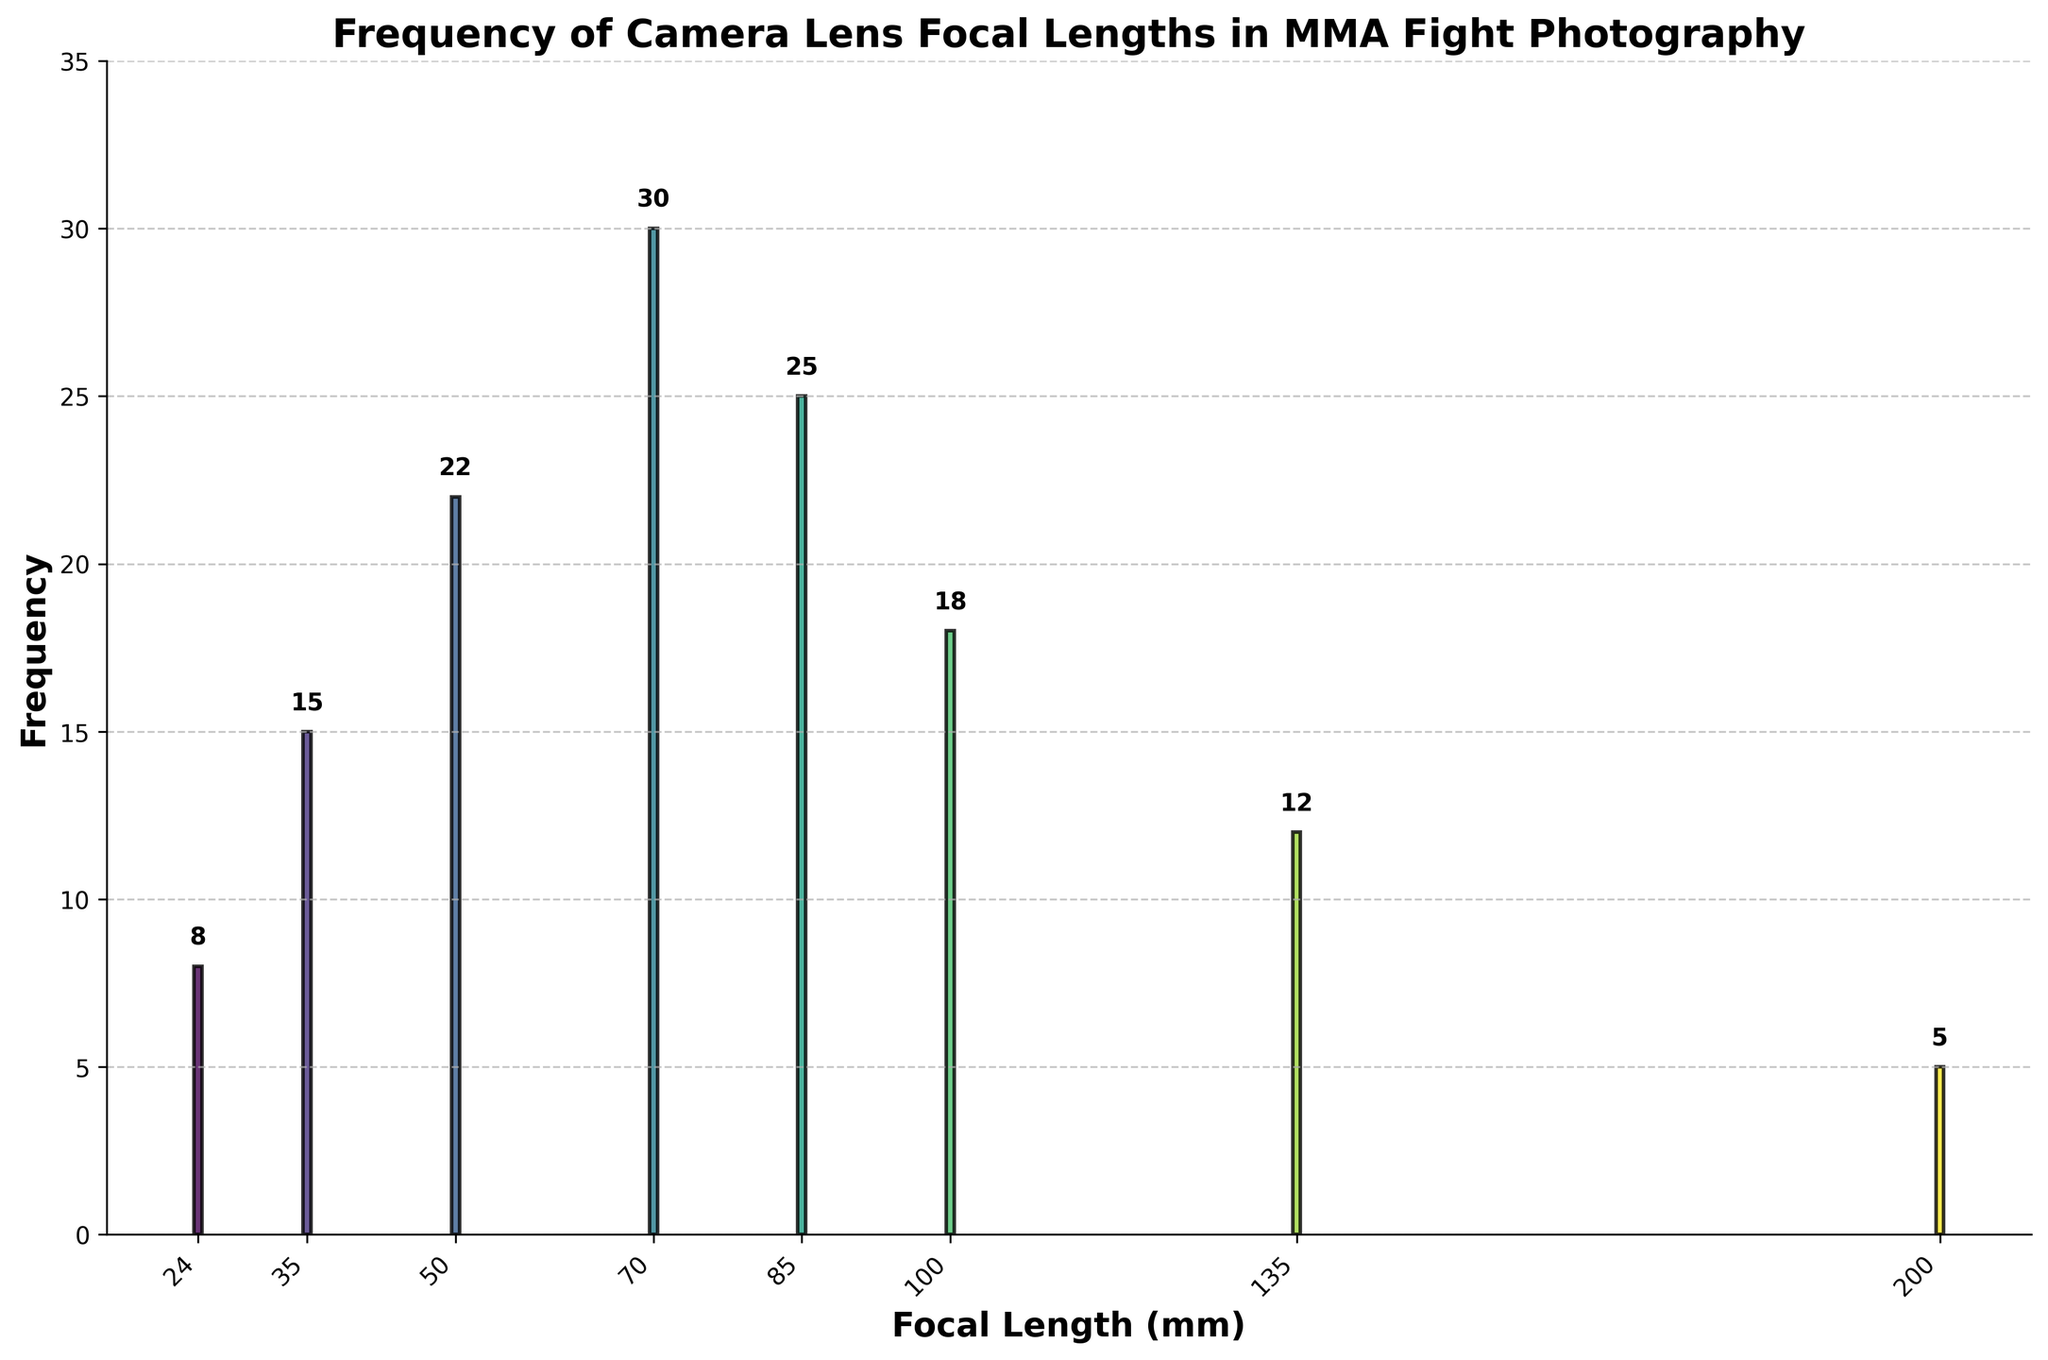What is the title of the figure? The title of the figure is displayed at the top in bold text.
Answer: Frequency of Camera Lens Focal Lengths in MMA Fight Photography Which focal length was used most frequently? The focal length with the highest bar indicates the most frequently used. According to the figure, the highest bar is at 70mm with a frequency of 30.
Answer: 70mm How many focal lengths are represented in the histogram? Each unique focal length corresponds to one bar in the histogram. Counting these bars gives the number of focal lengths represented.
Answer: 8 What is the combined frequency of the 24mm and 200mm focal lengths? The frequency of 24mm is 8 and for 200mm is 5. Adding these frequencies together gives the combined frequency. 8 + 5 = 13
Answer: 13 Which focal length range (short: 24-50mm, medium: 70-100mm, long: 135-200mm) is most frequently used? The sum of frequencies within each focal length range determines which is most frequently used. The short range sums to 45 (8+15+22), the medium range sums to 73 (30+25+18), and the long range sums to 17 (12+5). The medium range has the highest sum.
Answer: Medium How does the frequency of the 100mm focal length compare to the 35mm focal length? The frequency of the 100mm focal length is 18, and the frequency of the 35mm focal length is 15. Comparatively, 100mm is used more frequently than 35mm.
Answer: 100mm > 35mm What is the average frequency of all the focal lengths? Sum all frequencies and then divide by the number of focal lengths: (8+15+22+30+25+18+12+5) = 135. The number of focal lengths is 8. 135 / 8 = 16.875.
Answer: 16.875 Is there a focal length with a frequency exactly in the middle (median) of the set? To find the median, list frequencies in order: 5, 8, 12, 15, 18, 22, 25, 30. The middle two frequencies are 15 and 18. The median is the average of these two: (15+18)/2 = 16.5. No single focal length has this exact frequency.
Answer: No 